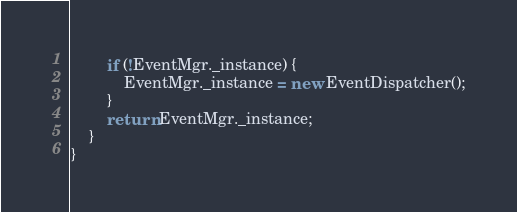Convert code to text. <code><loc_0><loc_0><loc_500><loc_500><_TypeScript_>        if (!EventMgr._instance) {
            EventMgr._instance = new EventDispatcher();
        }
        return EventMgr._instance;
    }
}
</code> 